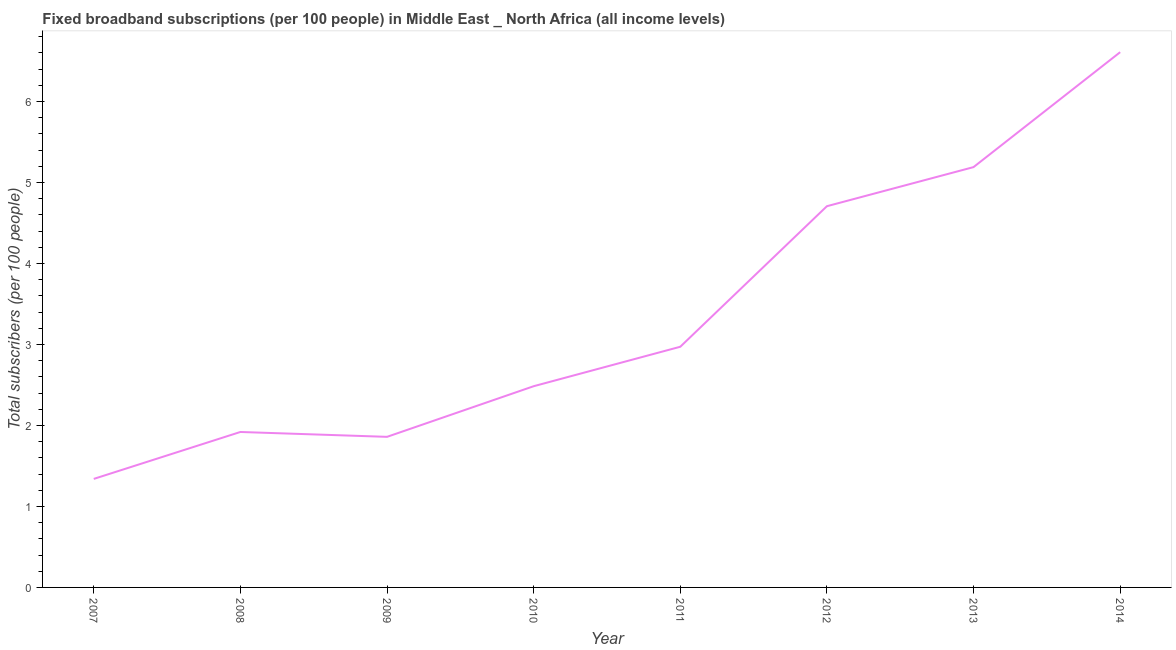What is the total number of fixed broadband subscriptions in 2013?
Provide a succinct answer. 5.19. Across all years, what is the maximum total number of fixed broadband subscriptions?
Keep it short and to the point. 6.61. Across all years, what is the minimum total number of fixed broadband subscriptions?
Provide a succinct answer. 1.34. In which year was the total number of fixed broadband subscriptions maximum?
Make the answer very short. 2014. What is the sum of the total number of fixed broadband subscriptions?
Offer a terse response. 27.08. What is the difference between the total number of fixed broadband subscriptions in 2012 and 2013?
Offer a very short reply. -0.48. What is the average total number of fixed broadband subscriptions per year?
Offer a very short reply. 3.39. What is the median total number of fixed broadband subscriptions?
Your answer should be compact. 2.73. What is the ratio of the total number of fixed broadband subscriptions in 2011 to that in 2012?
Provide a short and direct response. 0.63. Is the difference between the total number of fixed broadband subscriptions in 2010 and 2014 greater than the difference between any two years?
Your answer should be very brief. No. What is the difference between the highest and the second highest total number of fixed broadband subscriptions?
Your answer should be very brief. 1.42. What is the difference between the highest and the lowest total number of fixed broadband subscriptions?
Offer a terse response. 5.27. In how many years, is the total number of fixed broadband subscriptions greater than the average total number of fixed broadband subscriptions taken over all years?
Ensure brevity in your answer.  3. How many lines are there?
Your answer should be compact. 1. What is the difference between two consecutive major ticks on the Y-axis?
Offer a terse response. 1. Are the values on the major ticks of Y-axis written in scientific E-notation?
Keep it short and to the point. No. What is the title of the graph?
Give a very brief answer. Fixed broadband subscriptions (per 100 people) in Middle East _ North Africa (all income levels). What is the label or title of the X-axis?
Make the answer very short. Year. What is the label or title of the Y-axis?
Your answer should be compact. Total subscribers (per 100 people). What is the Total subscribers (per 100 people) in 2007?
Offer a very short reply. 1.34. What is the Total subscribers (per 100 people) in 2008?
Provide a succinct answer. 1.92. What is the Total subscribers (per 100 people) of 2009?
Keep it short and to the point. 1.86. What is the Total subscribers (per 100 people) of 2010?
Your answer should be compact. 2.48. What is the Total subscribers (per 100 people) in 2011?
Keep it short and to the point. 2.97. What is the Total subscribers (per 100 people) in 2012?
Provide a short and direct response. 4.71. What is the Total subscribers (per 100 people) of 2013?
Provide a short and direct response. 5.19. What is the Total subscribers (per 100 people) of 2014?
Ensure brevity in your answer.  6.61. What is the difference between the Total subscribers (per 100 people) in 2007 and 2008?
Provide a succinct answer. -0.58. What is the difference between the Total subscribers (per 100 people) in 2007 and 2009?
Your answer should be very brief. -0.52. What is the difference between the Total subscribers (per 100 people) in 2007 and 2010?
Keep it short and to the point. -1.14. What is the difference between the Total subscribers (per 100 people) in 2007 and 2011?
Provide a succinct answer. -1.63. What is the difference between the Total subscribers (per 100 people) in 2007 and 2012?
Offer a very short reply. -3.37. What is the difference between the Total subscribers (per 100 people) in 2007 and 2013?
Give a very brief answer. -3.85. What is the difference between the Total subscribers (per 100 people) in 2007 and 2014?
Your answer should be compact. -5.27. What is the difference between the Total subscribers (per 100 people) in 2008 and 2009?
Your response must be concise. 0.06. What is the difference between the Total subscribers (per 100 people) in 2008 and 2010?
Offer a very short reply. -0.56. What is the difference between the Total subscribers (per 100 people) in 2008 and 2011?
Keep it short and to the point. -1.05. What is the difference between the Total subscribers (per 100 people) in 2008 and 2012?
Offer a very short reply. -2.79. What is the difference between the Total subscribers (per 100 people) in 2008 and 2013?
Offer a terse response. -3.27. What is the difference between the Total subscribers (per 100 people) in 2008 and 2014?
Your response must be concise. -4.69. What is the difference between the Total subscribers (per 100 people) in 2009 and 2010?
Offer a terse response. -0.63. What is the difference between the Total subscribers (per 100 people) in 2009 and 2011?
Offer a terse response. -1.11. What is the difference between the Total subscribers (per 100 people) in 2009 and 2012?
Provide a short and direct response. -2.85. What is the difference between the Total subscribers (per 100 people) in 2009 and 2013?
Offer a very short reply. -3.33. What is the difference between the Total subscribers (per 100 people) in 2009 and 2014?
Your response must be concise. -4.75. What is the difference between the Total subscribers (per 100 people) in 2010 and 2011?
Make the answer very short. -0.49. What is the difference between the Total subscribers (per 100 people) in 2010 and 2012?
Give a very brief answer. -2.22. What is the difference between the Total subscribers (per 100 people) in 2010 and 2013?
Provide a succinct answer. -2.71. What is the difference between the Total subscribers (per 100 people) in 2010 and 2014?
Offer a terse response. -4.12. What is the difference between the Total subscribers (per 100 people) in 2011 and 2012?
Your answer should be very brief. -1.74. What is the difference between the Total subscribers (per 100 people) in 2011 and 2013?
Your answer should be compact. -2.22. What is the difference between the Total subscribers (per 100 people) in 2011 and 2014?
Make the answer very short. -3.64. What is the difference between the Total subscribers (per 100 people) in 2012 and 2013?
Your answer should be compact. -0.48. What is the difference between the Total subscribers (per 100 people) in 2012 and 2014?
Make the answer very short. -1.9. What is the difference between the Total subscribers (per 100 people) in 2013 and 2014?
Provide a short and direct response. -1.42. What is the ratio of the Total subscribers (per 100 people) in 2007 to that in 2008?
Provide a succinct answer. 0.7. What is the ratio of the Total subscribers (per 100 people) in 2007 to that in 2009?
Keep it short and to the point. 0.72. What is the ratio of the Total subscribers (per 100 people) in 2007 to that in 2010?
Give a very brief answer. 0.54. What is the ratio of the Total subscribers (per 100 people) in 2007 to that in 2011?
Provide a succinct answer. 0.45. What is the ratio of the Total subscribers (per 100 people) in 2007 to that in 2012?
Offer a very short reply. 0.28. What is the ratio of the Total subscribers (per 100 people) in 2007 to that in 2013?
Offer a terse response. 0.26. What is the ratio of the Total subscribers (per 100 people) in 2007 to that in 2014?
Give a very brief answer. 0.2. What is the ratio of the Total subscribers (per 100 people) in 2008 to that in 2009?
Provide a short and direct response. 1.03. What is the ratio of the Total subscribers (per 100 people) in 2008 to that in 2010?
Give a very brief answer. 0.77. What is the ratio of the Total subscribers (per 100 people) in 2008 to that in 2011?
Your answer should be compact. 0.65. What is the ratio of the Total subscribers (per 100 people) in 2008 to that in 2012?
Your answer should be very brief. 0.41. What is the ratio of the Total subscribers (per 100 people) in 2008 to that in 2013?
Your answer should be compact. 0.37. What is the ratio of the Total subscribers (per 100 people) in 2008 to that in 2014?
Keep it short and to the point. 0.29. What is the ratio of the Total subscribers (per 100 people) in 2009 to that in 2010?
Your response must be concise. 0.75. What is the ratio of the Total subscribers (per 100 people) in 2009 to that in 2011?
Your response must be concise. 0.63. What is the ratio of the Total subscribers (per 100 people) in 2009 to that in 2012?
Your answer should be compact. 0.4. What is the ratio of the Total subscribers (per 100 people) in 2009 to that in 2013?
Your response must be concise. 0.36. What is the ratio of the Total subscribers (per 100 people) in 2009 to that in 2014?
Your answer should be compact. 0.28. What is the ratio of the Total subscribers (per 100 people) in 2010 to that in 2011?
Ensure brevity in your answer.  0.84. What is the ratio of the Total subscribers (per 100 people) in 2010 to that in 2012?
Give a very brief answer. 0.53. What is the ratio of the Total subscribers (per 100 people) in 2010 to that in 2013?
Your response must be concise. 0.48. What is the ratio of the Total subscribers (per 100 people) in 2010 to that in 2014?
Ensure brevity in your answer.  0.38. What is the ratio of the Total subscribers (per 100 people) in 2011 to that in 2012?
Ensure brevity in your answer.  0.63. What is the ratio of the Total subscribers (per 100 people) in 2011 to that in 2013?
Ensure brevity in your answer.  0.57. What is the ratio of the Total subscribers (per 100 people) in 2011 to that in 2014?
Offer a terse response. 0.45. What is the ratio of the Total subscribers (per 100 people) in 2012 to that in 2013?
Give a very brief answer. 0.91. What is the ratio of the Total subscribers (per 100 people) in 2012 to that in 2014?
Ensure brevity in your answer.  0.71. What is the ratio of the Total subscribers (per 100 people) in 2013 to that in 2014?
Give a very brief answer. 0.79. 